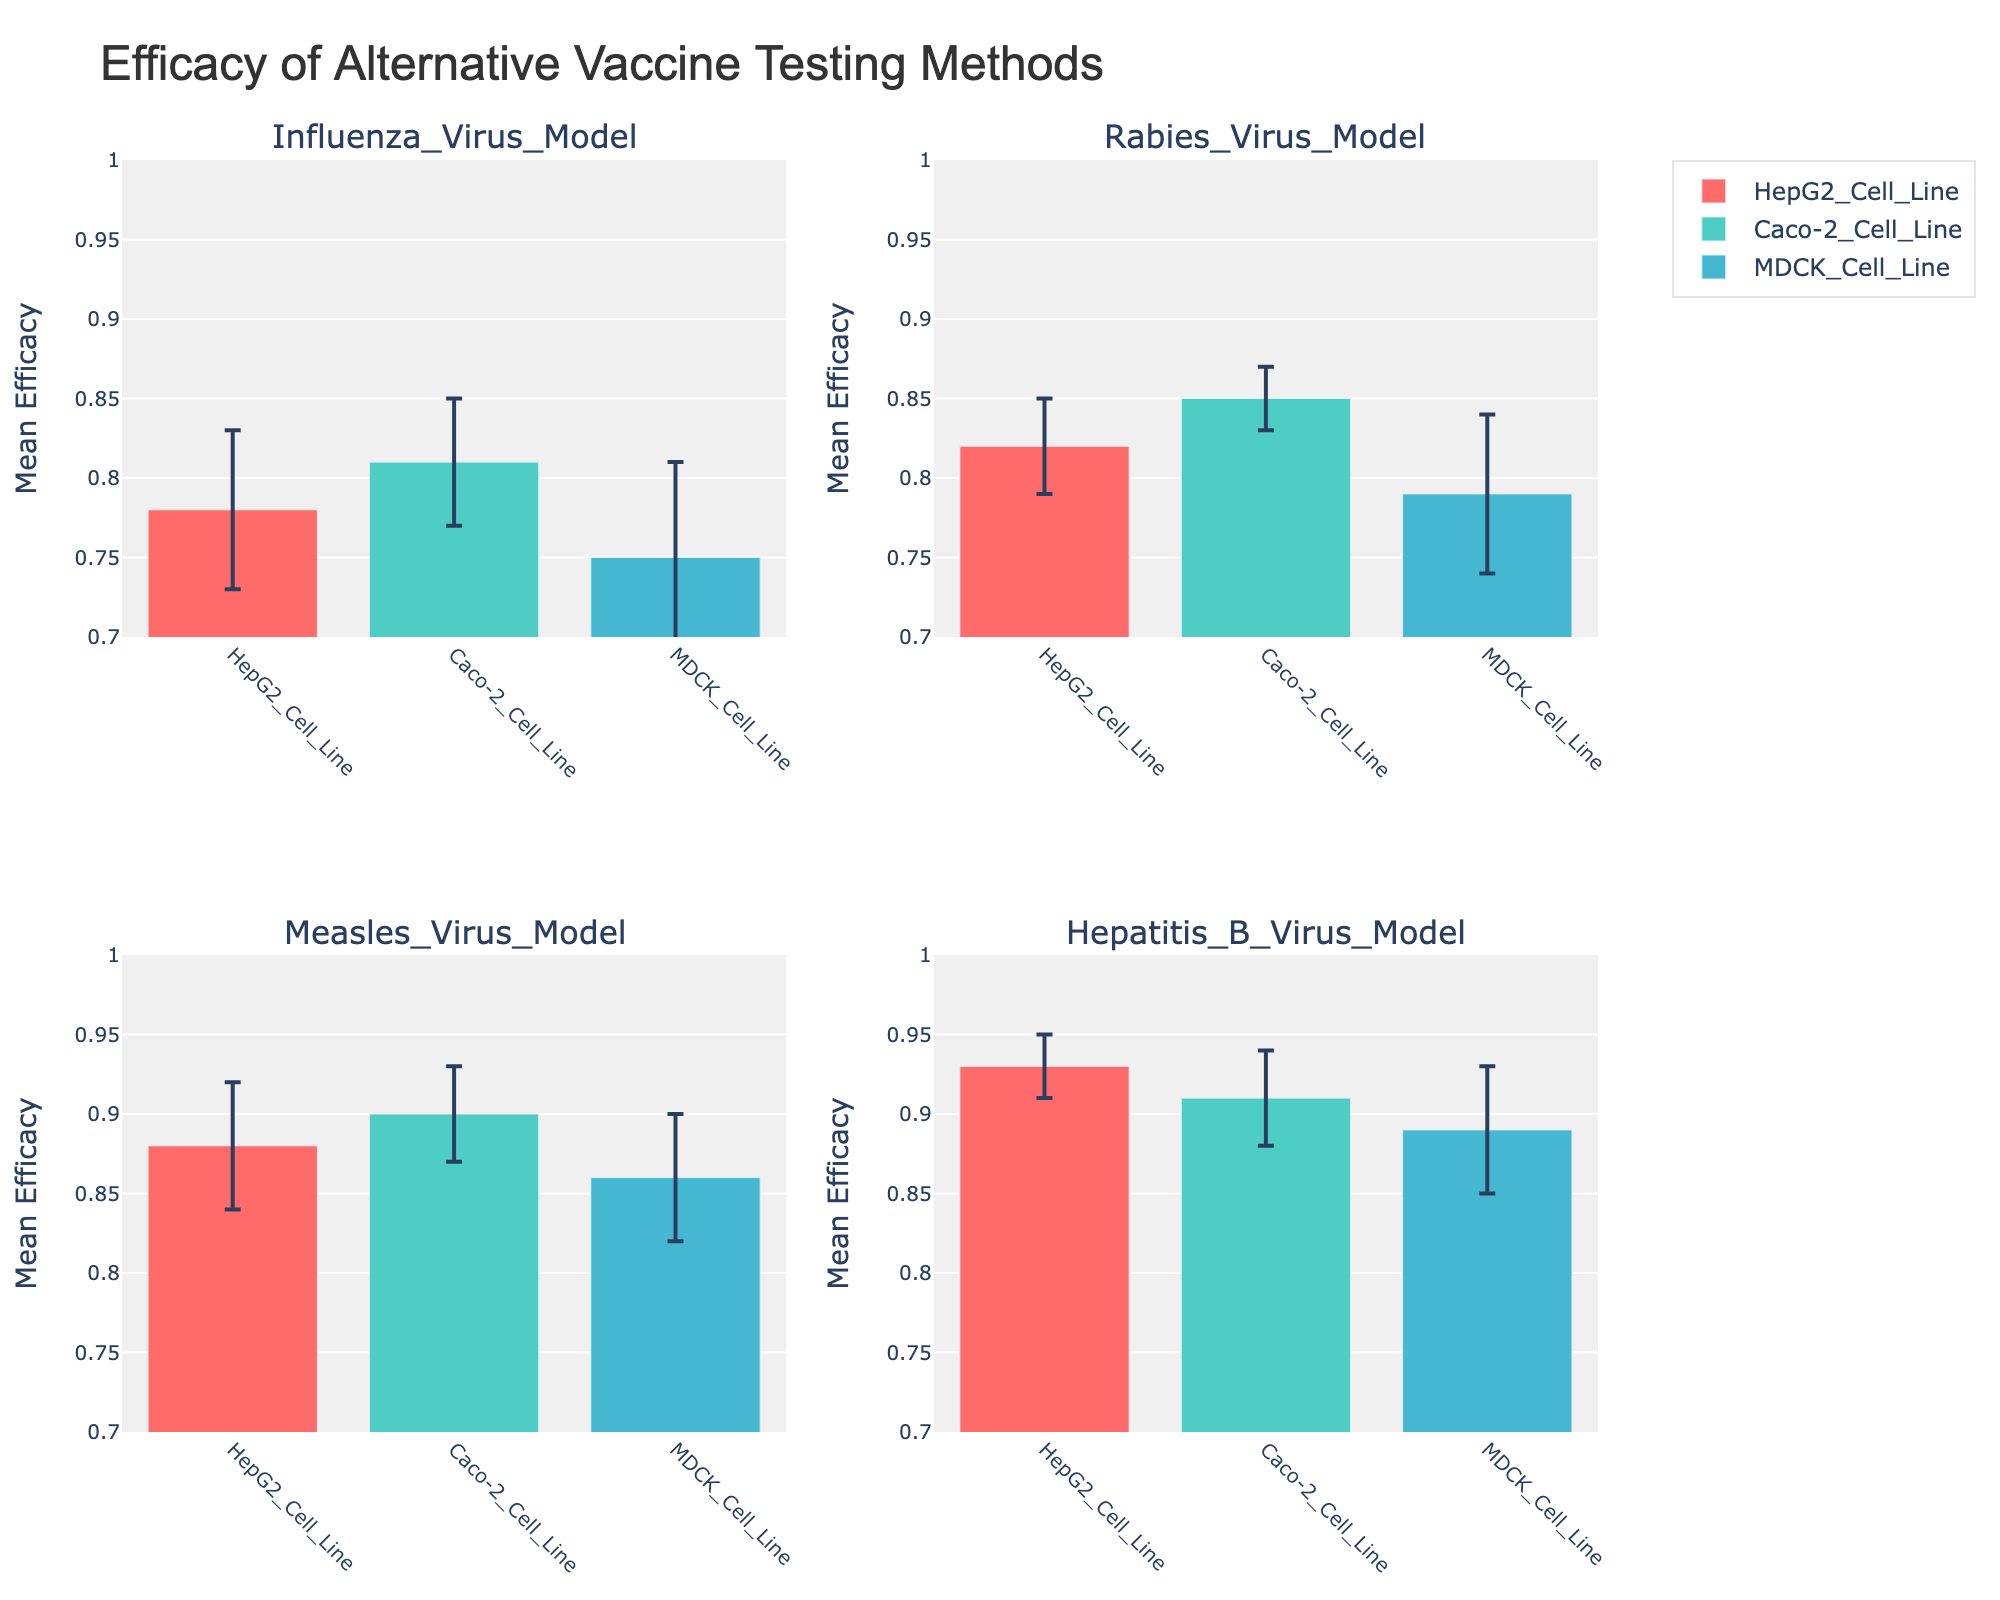Which vaccine model has the highest mean efficacy using the HepG2 Cell Line method? The highest mean efficacy using the HepG2 Cell Line method is shown in the subplot titled "Hepatitis B Virus Model" with a value of 0.93.
Answer: Hepatitis B Virus Model What is the mean efficacy for the MDCK Cell Line method in the Measles Virus Model? The mean efficacy for the MDCK Cell Line method in the Measles Virus Model is displayed as a bar in the corresponding subplot with a value of 0.86.
Answer: 0.86 Which vaccine model and cell line combination has the largest standard deviation? The largest standard deviation is depicted by the longest error bars. The MDCK Cell Line in the Influenza Virus Model has the largest standard deviation with a value of 0.06.
Answer: Influenza Virus Model, MDCK Cell Line How does the mean efficacy of the Caco-2 Cell Line compare between the Rabies Virus Model and Measles Virus Model? To compare the mean efficacy, look at the bars in both virus models. Caco-2 Cell Line has a mean efficacy of 0.85 in the Rabies Virus Model and 0.90 in the Measles Virus Model. Thus, it is higher in the Measles Virus Model.
Answer: Measles Virus Model is higher What is the difference in mean efficacy between the HepG2 and MDCK Cell Line methods in the Rabies Virus Model? The mean efficacy for the HepG2 Cell Line in the Rabies Virus Model is 0.82, and for the MDCK Cell Line, it is 0.79. The difference is 0.82 - 0.79.
Answer: 0.03 Which cell line shows the most consistent efficacy across all vaccine models? Consistency is evaluated by examining the shortest error bars across all subplots. The Caco-2 Cell Line has the shortest error bars, indicating the smallest standard deviation in all vaccine models.
Answer: Caco-2 Cell Line What is the average mean efficacy of all cell line methods combined in the Hepatitis B Virus Model? For HepG2 Cell Line (0.93), Caco-2 Cell Line (0.91), and MDCK Cell Line (0.89), sum the mean efficacies and divide by 3: (0.93 + 0.91 + 0.89) / 3 = 0.91
Answer: 0.91 